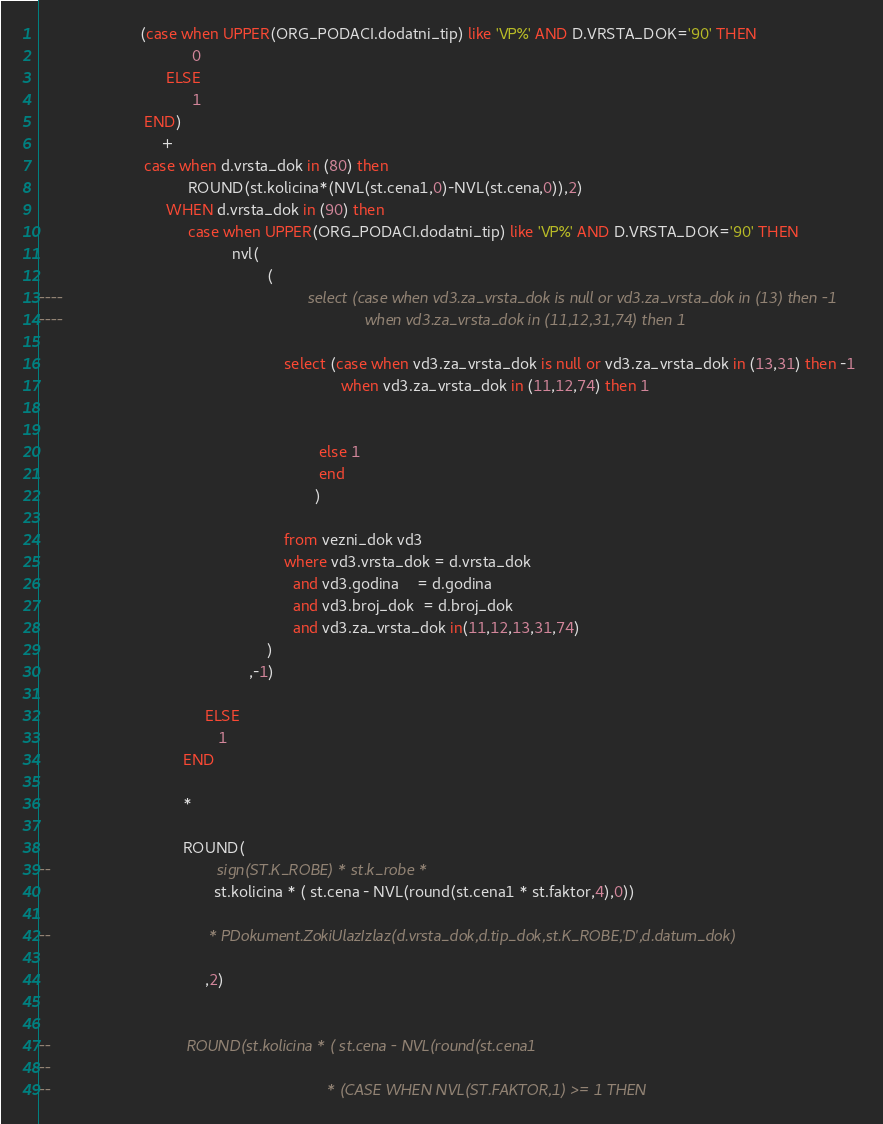Convert code to text. <code><loc_0><loc_0><loc_500><loc_500><_SQL_>	                   (case when UPPER(ORG_PODACI.dodatni_tip) like 'VP%' AND D.VRSTA_DOK='90' THEN
	                               0
	                         ELSE
	                               1
	                    END)
                            +
	                    case when d.vrsta_dok in (80) then
	                              ROUND(st.kolicina*(NVL(st.cena1,0)-NVL(st.cena,0)),2)
	                         WHEN d.vrsta_dok in (90) then
	                              case when UPPER(ORG_PODACI.dodatni_tip) like 'VP%' AND D.VRSTA_DOK='90' THEN
	                                        nvl(
	                	                            (
----	                	                             	select (case when vd3.za_vrsta_dok is null or vd3.za_vrsta_dok in (13) then -1
----	                	                                	     	 when vd3.za_vrsta_dok in (11,12,31,74) then 1

 	                	                             	select (case when vd3.za_vrsta_dok is null or vd3.za_vrsta_dok in (13,31) then -1
	                	                                	     	 when vd3.za_vrsta_dok in (11,12,74) then 1


	                	                               		    else 1
	                	                               		    end
	                	                               		   )

	                     						 	 	from vezni_dok vd3
											     	 	where vd3.vrsta_dok = d.vrsta_dok
											              and vd3.godina    = d.godina
											              and vd3.broj_dok  = d.broj_dok
											              and vd3.za_vrsta_dok in(11,12,13,31,74)
											        )
												,-1)

	                                  ELSE
	                                     1
	                             END

	                             *

	                             ROUND(
--	                                    sign(ST.K_ROBE) * st.k_robe *
	                                    st.kolicina * ( st.cena - NVL(round(st.cena1 * st.faktor,4),0))

--	                                  * PDokument.ZokiUlazIzlaz(d.vrsta_dok,d.tip_dok,st.K_ROBE,'D',d.datum_dok)

	                                  ,2)


--	                             ROUND(st.kolicina * ( st.cena - NVL(round(st.cena1
--
--						                                         * (CASE WHEN NVL(ST.FAKTOR,1) >= 1 THEN</code> 